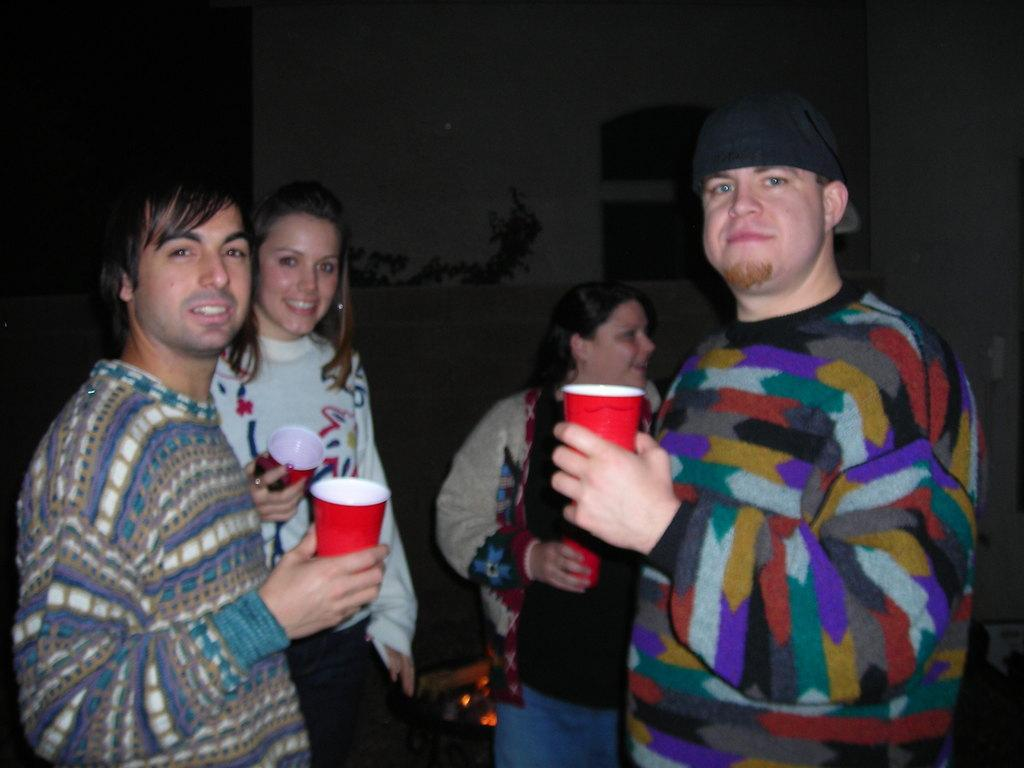What can be seen in the image? There are people standing in the image. Where are the people standing? The people are standing on the floor. What are the people holding in their hands? The people are holding disposable tumblers in their hands. What type of furniture can be seen in the image? There is no furniture present in the image; it only shows people standing on the floor and holding disposable tumblers. 